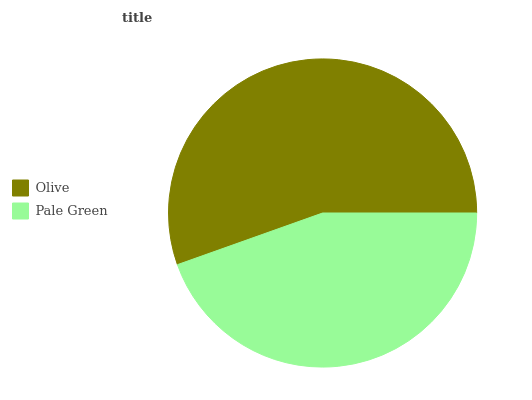Is Pale Green the minimum?
Answer yes or no. Yes. Is Olive the maximum?
Answer yes or no. Yes. Is Pale Green the maximum?
Answer yes or no. No. Is Olive greater than Pale Green?
Answer yes or no. Yes. Is Pale Green less than Olive?
Answer yes or no. Yes. Is Pale Green greater than Olive?
Answer yes or no. No. Is Olive less than Pale Green?
Answer yes or no. No. Is Olive the high median?
Answer yes or no. Yes. Is Pale Green the low median?
Answer yes or no. Yes. Is Pale Green the high median?
Answer yes or no. No. Is Olive the low median?
Answer yes or no. No. 